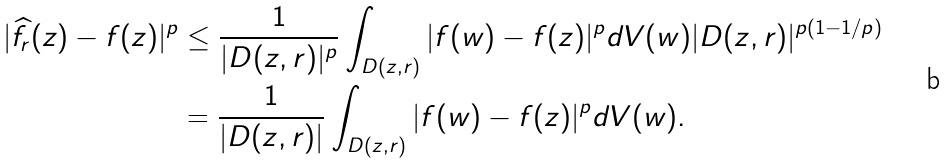Convert formula to latex. <formula><loc_0><loc_0><loc_500><loc_500>| \widehat { f } _ { r } ( z ) - f ( z ) | ^ { p } & \leq \frac { 1 } { | D ( z , r ) | ^ { p } } \int _ { D ( z , r ) } | f ( w ) - f ( z ) | ^ { p } d V ( w ) | D ( z , r ) | ^ { p ( 1 - 1 / p ) } \\ & = \frac { 1 } { | D ( z , r ) | } \int _ { D ( z , r ) } | f ( w ) - f ( z ) | ^ { p } d V ( w ) .</formula> 